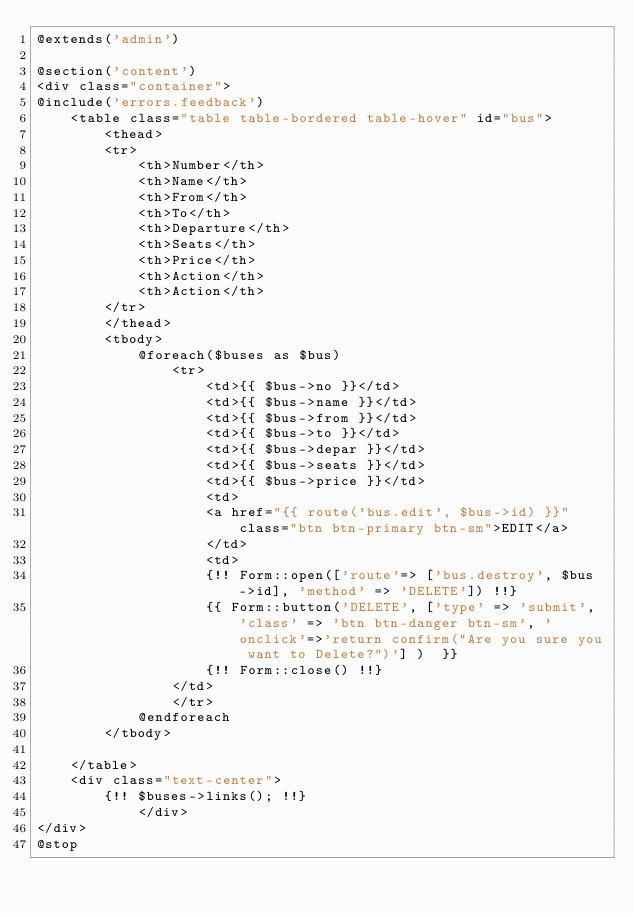<code> <loc_0><loc_0><loc_500><loc_500><_PHP_>@extends('admin')

@section('content')
<div class="container">
@include('errors.feedback')
    <table class="table table-bordered table-hover" id="bus">
        <thead>
        <tr>
            <th>Number</th>
            <th>Name</th>
            <th>From</th>
            <th>To</th>
            <th>Departure</th>
            <th>Seats</th>
            <th>Price</th>
            <th>Action</th>
            <th>Action</th>
        </tr>
        </thead>
        <tbody>
            @foreach($buses as $bus)
                <tr>
                    <td>{{ $bus->no }}</td>
                    <td>{{ $bus->name }}</td>
                    <td>{{ $bus->from }}</td>
                    <td>{{ $bus->to }}</td>
                    <td>{{ $bus->depar }}</td>
                    <td>{{ $bus->seats }}</td>
                    <td>{{ $bus->price }}</td>
                    <td>
                    <a href="{{ route('bus.edit', $bus->id) }}" class="btn btn-primary btn-sm">EDIT</a>
                    </td>
                    <td>
                    {!! Form::open(['route'=> ['bus.destroy', $bus->id], 'method' => 'DELETE']) !!}
                    {{ Form::button('DELETE', ['type' => 'submit', 'class' => 'btn btn-danger btn-sm', 'onclick'=>'return confirm("Are you sure you want to Delete?")'] )  }}
                    {!! Form::close() !!}
                </td>
                </tr>
            @endforeach
        </tbody>

    </table>
    <div class="text-center">
				{!! $buses->links(); !!}
            </div>
</div>
@stop</code> 